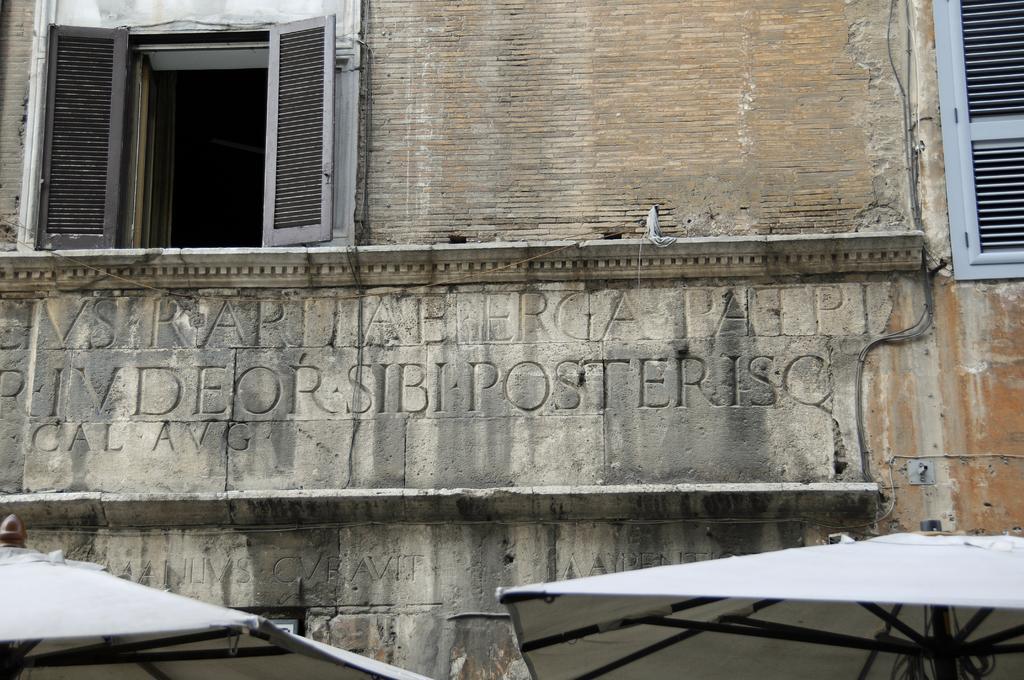Can you describe this image briefly? This is an outdoor picture. Here we can see a building and it seems like an old building. Here we can see the windows opened and there is something written on the wall of the building. In the front portion of the picture we can see two umbrellas which are white in colour. 